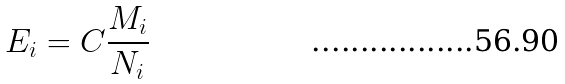<formula> <loc_0><loc_0><loc_500><loc_500>E _ { i } = C \frac { M _ { i } } { N _ { i } }</formula> 